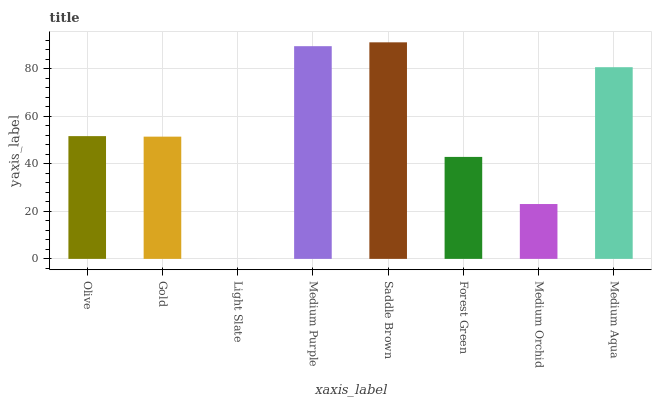Is Light Slate the minimum?
Answer yes or no. Yes. Is Saddle Brown the maximum?
Answer yes or no. Yes. Is Gold the minimum?
Answer yes or no. No. Is Gold the maximum?
Answer yes or no. No. Is Olive greater than Gold?
Answer yes or no. Yes. Is Gold less than Olive?
Answer yes or no. Yes. Is Gold greater than Olive?
Answer yes or no. No. Is Olive less than Gold?
Answer yes or no. No. Is Olive the high median?
Answer yes or no. Yes. Is Gold the low median?
Answer yes or no. Yes. Is Light Slate the high median?
Answer yes or no. No. Is Forest Green the low median?
Answer yes or no. No. 